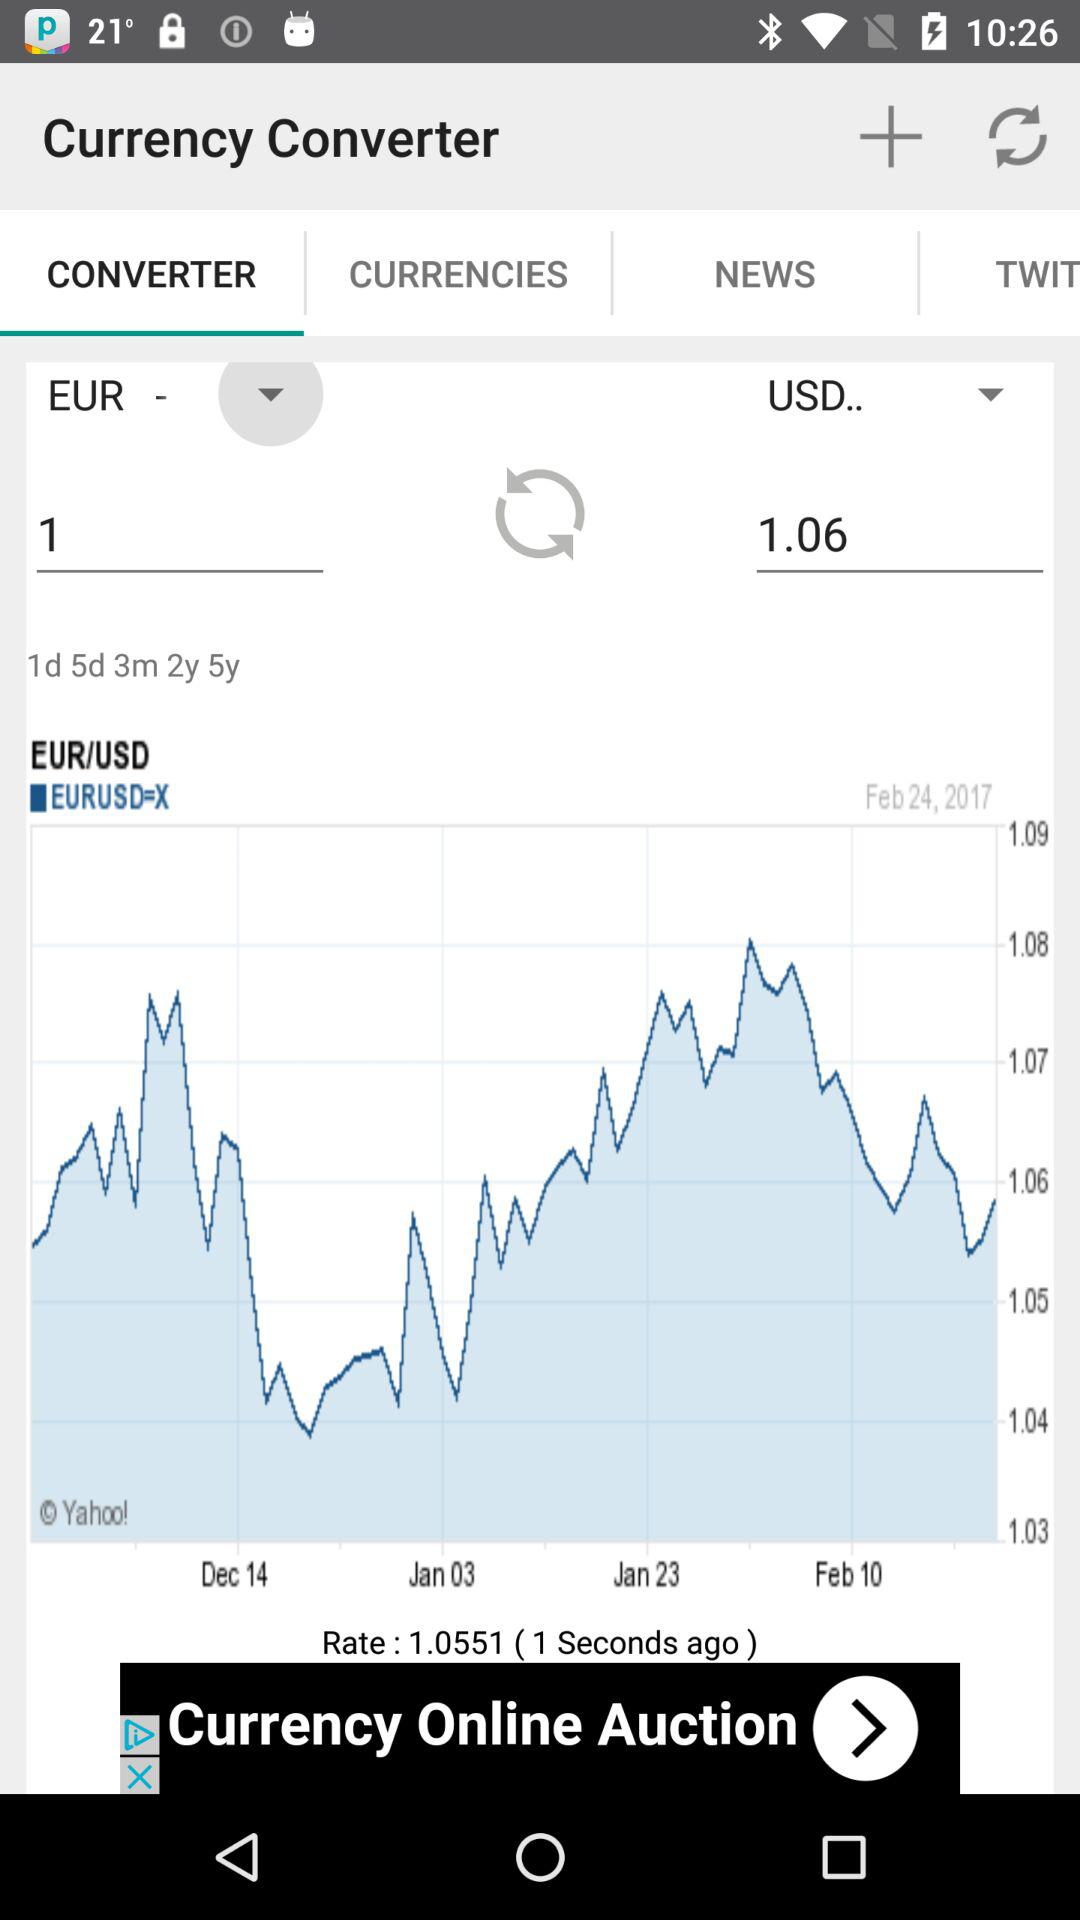What was the rate one second ago? The rate was 1.0551 one second ago. 